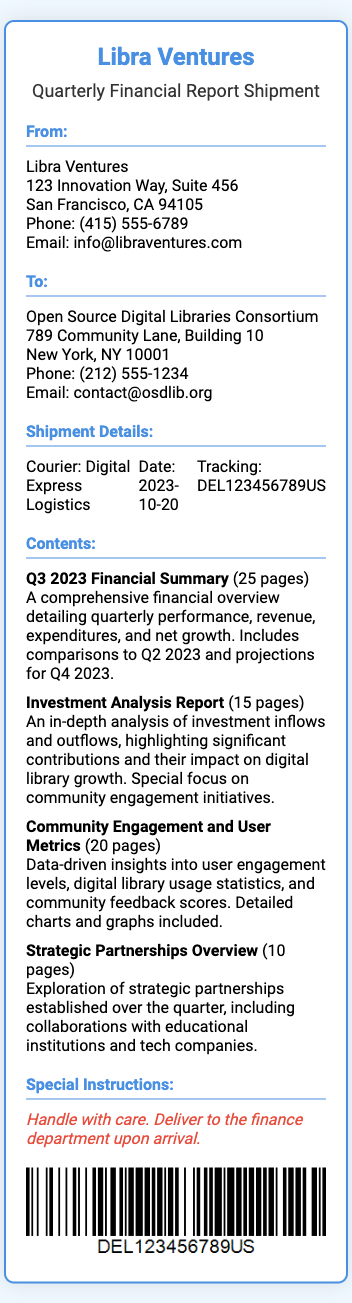What is the name of the courier? The courier handling the shipment is mentioned in the document.
Answer: Digital Express Logistics What is the date of the shipment? The shipment date is clearly provided in the document.
Answer: 2023-10-20 Who is the sender of the report? The sender's details are listed at the top of the document.
Answer: Libra Ventures What is the total number of pages in the Q3 2023 Financial Summary? The document specifies the number of pages for the Q3 report.
Answer: 25 pages What type of report is the last content item listed? The last item listed under contents specifies its type.
Answer: Strategic Partnerships Overview What special instructions are provided for the delivery? Special handling instructions are included in the document.
Answer: Handle with care. Deliver to the finance department upon arrival What is the phone number of the recipient? The document lists the recipient's phone number clearly.
Answer: (212) 555-1234 How many pages are in the Investment Analysis Report? The document provides the page count for this specific report.
Answer: 15 pages What is the email of the sender? The sender's email address is provided in the address section.
Answer: info@libraventures.com 